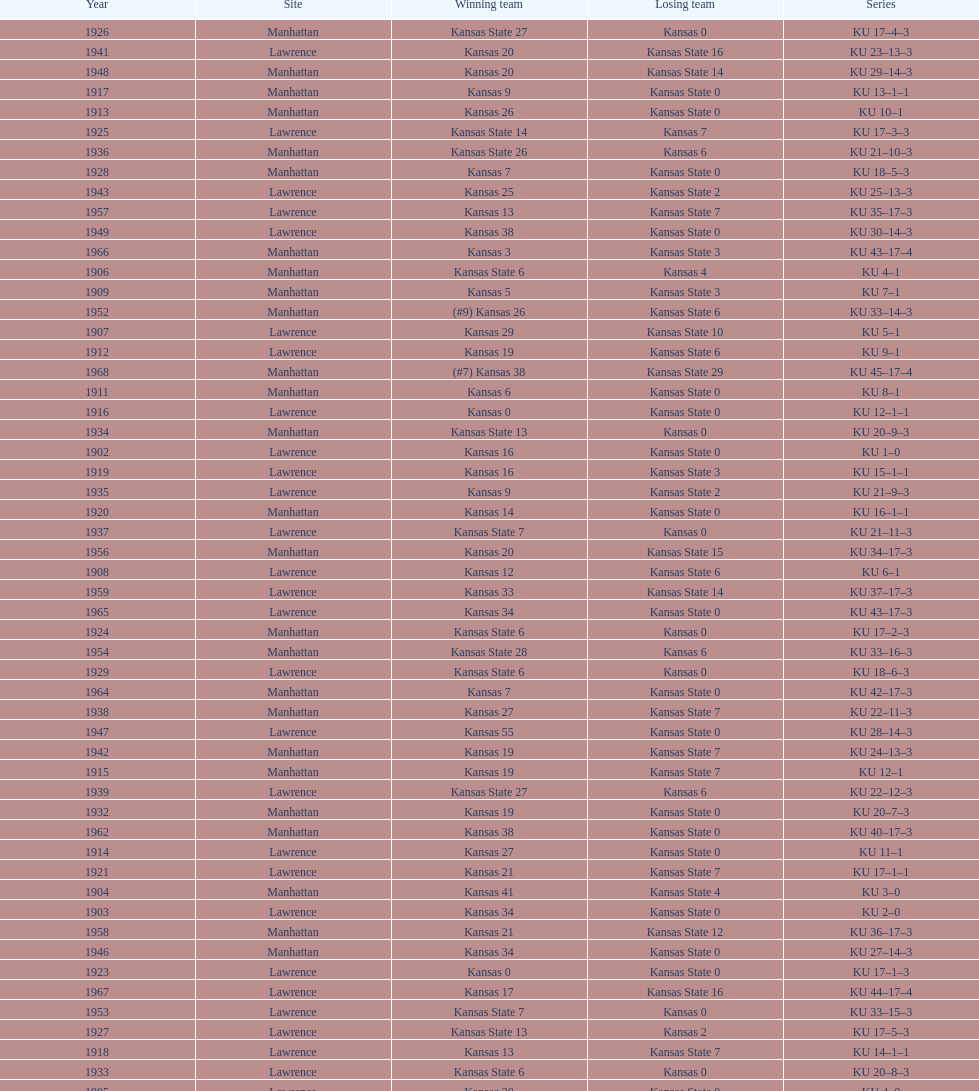Who had the most wins in the 1950's: kansas or kansas state? Kansas. Could you parse the entire table? {'header': ['Year', 'Site', 'Winning team', 'Losing team', 'Series'], 'rows': [['1926', 'Manhattan', 'Kansas State 27', 'Kansas 0', 'KU 17–4–3'], ['1941', 'Lawrence', 'Kansas 20', 'Kansas State 16', 'KU 23–13–3'], ['1948', 'Manhattan', 'Kansas 20', 'Kansas State 14', 'KU 29–14–3'], ['1917', 'Manhattan', 'Kansas 9', 'Kansas State 0', 'KU 13–1–1'], ['1913', 'Manhattan', 'Kansas 26', 'Kansas State 0', 'KU 10–1'], ['1925', 'Lawrence', 'Kansas State 14', 'Kansas 7', 'KU 17–3–3'], ['1936', 'Manhattan', 'Kansas State 26', 'Kansas 6', 'KU 21–10–3'], ['1928', 'Manhattan', 'Kansas 7', 'Kansas State 0', 'KU 18–5–3'], ['1943', 'Lawrence', 'Kansas 25', 'Kansas State 2', 'KU 25–13–3'], ['1957', 'Lawrence', 'Kansas 13', 'Kansas State 7', 'KU 35–17–3'], ['1949', 'Lawrence', 'Kansas 38', 'Kansas State 0', 'KU 30–14–3'], ['1966', 'Manhattan', 'Kansas 3', 'Kansas State 3', 'KU 43–17–4'], ['1906', 'Manhattan', 'Kansas State 6', 'Kansas 4', 'KU 4–1'], ['1909', 'Manhattan', 'Kansas 5', 'Kansas State 3', 'KU 7–1'], ['1952', 'Manhattan', '(#9) Kansas 26', 'Kansas State 6', 'KU 33–14–3'], ['1907', 'Lawrence', 'Kansas 29', 'Kansas State 10', 'KU 5–1'], ['1912', 'Lawrence', 'Kansas 19', 'Kansas State 6', 'KU 9–1'], ['1968', 'Manhattan', '(#7) Kansas 38', 'Kansas State 29', 'KU 45–17–4'], ['1911', 'Manhattan', 'Kansas 6', 'Kansas State 0', 'KU 8–1'], ['1916', 'Lawrence', 'Kansas 0', 'Kansas State 0', 'KU 12–1–1'], ['1934', 'Manhattan', 'Kansas State 13', 'Kansas 0', 'KU 20–9–3'], ['1902', 'Lawrence', 'Kansas 16', 'Kansas State 0', 'KU 1–0'], ['1919', 'Lawrence', 'Kansas 16', 'Kansas State 3', 'KU 15–1–1'], ['1935', 'Lawrence', 'Kansas 9', 'Kansas State 2', 'KU 21–9–3'], ['1920', 'Manhattan', 'Kansas 14', 'Kansas State 0', 'KU 16–1–1'], ['1937', 'Lawrence', 'Kansas State 7', 'Kansas 0', 'KU 21–11–3'], ['1956', 'Manhattan', 'Kansas 20', 'Kansas State 15', 'KU 34–17–3'], ['1908', 'Lawrence', 'Kansas 12', 'Kansas State 6', 'KU 6–1'], ['1959', 'Lawrence', 'Kansas 33', 'Kansas State 14', 'KU 37–17–3'], ['1965', 'Lawrence', 'Kansas 34', 'Kansas State 0', 'KU 43–17–3'], ['1924', 'Manhattan', 'Kansas State 6', 'Kansas 0', 'KU 17–2–3'], ['1954', 'Manhattan', 'Kansas State 28', 'Kansas 6', 'KU 33–16–3'], ['1929', 'Lawrence', 'Kansas State 6', 'Kansas 0', 'KU 18–6–3'], ['1964', 'Manhattan', 'Kansas 7', 'Kansas State 0', 'KU 42–17–3'], ['1938', 'Manhattan', 'Kansas 27', 'Kansas State 7', 'KU 22–11–3'], ['1947', 'Lawrence', 'Kansas 55', 'Kansas State 0', 'KU 28–14–3'], ['1942', 'Manhattan', 'Kansas 19', 'Kansas State 7', 'KU 24–13–3'], ['1915', 'Manhattan', 'Kansas 19', 'Kansas State 7', 'KU 12–1'], ['1939', 'Lawrence', 'Kansas State 27', 'Kansas 6', 'KU 22–12–3'], ['1932', 'Manhattan', 'Kansas 19', 'Kansas State 0', 'KU 20–7–3'], ['1962', 'Manhattan', 'Kansas 38', 'Kansas State 0', 'KU 40–17–3'], ['1914', 'Lawrence', 'Kansas 27', 'Kansas State 0', 'KU 11–1'], ['1921', 'Lawrence', 'Kansas 21', 'Kansas State 7', 'KU 17–1–1'], ['1904', 'Manhattan', 'Kansas 41', 'Kansas State 4', 'KU 3–0'], ['1903', 'Lawrence', 'Kansas 34', 'Kansas State 0', 'KU 2–0'], ['1958', 'Manhattan', 'Kansas 21', 'Kansas State 12', 'KU 36–17–3'], ['1946', 'Manhattan', 'Kansas 34', 'Kansas State 0', 'KU 27–14–3'], ['1923', 'Lawrence', 'Kansas 0', 'Kansas State 0', 'KU 17–1–3'], ['1967', 'Lawrence', 'Kansas 17', 'Kansas State 16', 'KU 44–17–4'], ['1953', 'Lawrence', 'Kansas State 7', 'Kansas 0', 'KU 33–15–3'], ['1927', 'Lawrence', 'Kansas State 13', 'Kansas 2', 'KU 17–5–3'], ['1918', 'Lawrence', 'Kansas 13', 'Kansas State 7', 'KU 14–1–1'], ['1933', 'Lawrence', 'Kansas State 6', 'Kansas 0', 'KU 20–8–3'], ['1905', 'Lawrence', 'Kansas 28', 'Kansas State 0', 'KU 4–0'], ['1931', 'Lawrence', 'Kansas State 13', 'Kansas 0', 'KU 19–7–3'], ['1960', 'Manhattan', 'Kansas 41', 'Kansas State 0', 'KU 38–17–3'], ['1961', 'Lawrence', 'Kansas 34', 'Kansas State 0', 'KU 39–17–3'], ['1922', 'Manhattan', 'Kansas 7', 'Kansas State 7', 'KU 17–1–2'], ['1963', 'Lawrence', 'Kansas 34', 'Kansas State 0', 'KU 41–17–3'], ['1940', 'Manhattan', 'Kansas State 20', 'Kansas 0', 'KU 22–13–3'], ['1944', 'Manhattan', 'Kansas State 24', 'Kansas 18', 'KU 25–14–3'], ['1945', 'Lawrence', 'Kansas 27', 'Kansas State 0', 'KU 26–14–3'], ['1955', 'Lawrence', 'Kansas State 46', 'Kansas 0', 'KU 33–17–3'], ['1950', 'Manhattan', 'Kansas 47', 'Kansas State 7', 'KU 31–14–3'], ['1951', 'Lawrence', 'Kansas 33', 'Kansas State 14', 'KU 32–14–3'], ['1930', 'Manhattan', 'Kansas 14', 'Kansas State 0', 'KU 19–6–3']]} 